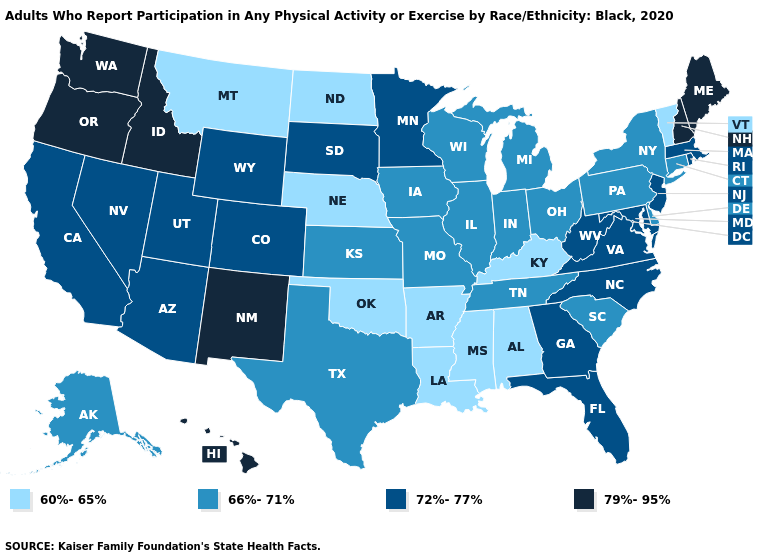Which states have the highest value in the USA?
Concise answer only. Hawaii, Idaho, Maine, New Hampshire, New Mexico, Oregon, Washington. What is the highest value in states that border Iowa?
Quick response, please. 72%-77%. Does Mississippi have a lower value than Kansas?
Give a very brief answer. Yes. What is the lowest value in the MidWest?
Quick response, please. 60%-65%. Does Vermont have the lowest value in the USA?
Keep it brief. Yes. Which states have the lowest value in the Northeast?
Be succinct. Vermont. Which states have the lowest value in the USA?
Write a very short answer. Alabama, Arkansas, Kentucky, Louisiana, Mississippi, Montana, Nebraska, North Dakota, Oklahoma, Vermont. Name the states that have a value in the range 60%-65%?
Keep it brief. Alabama, Arkansas, Kentucky, Louisiana, Mississippi, Montana, Nebraska, North Dakota, Oklahoma, Vermont. What is the value of Oregon?
Answer briefly. 79%-95%. What is the value of Colorado?
Answer briefly. 72%-77%. What is the value of Ohio?
Give a very brief answer. 66%-71%. Does Pennsylvania have a higher value than Montana?
Short answer required. Yes. Name the states that have a value in the range 72%-77%?
Write a very short answer. Arizona, California, Colorado, Florida, Georgia, Maryland, Massachusetts, Minnesota, Nevada, New Jersey, North Carolina, Rhode Island, South Dakota, Utah, Virginia, West Virginia, Wyoming. Among the states that border Mississippi , does Tennessee have the highest value?
Answer briefly. Yes. How many symbols are there in the legend?
Be succinct. 4. 